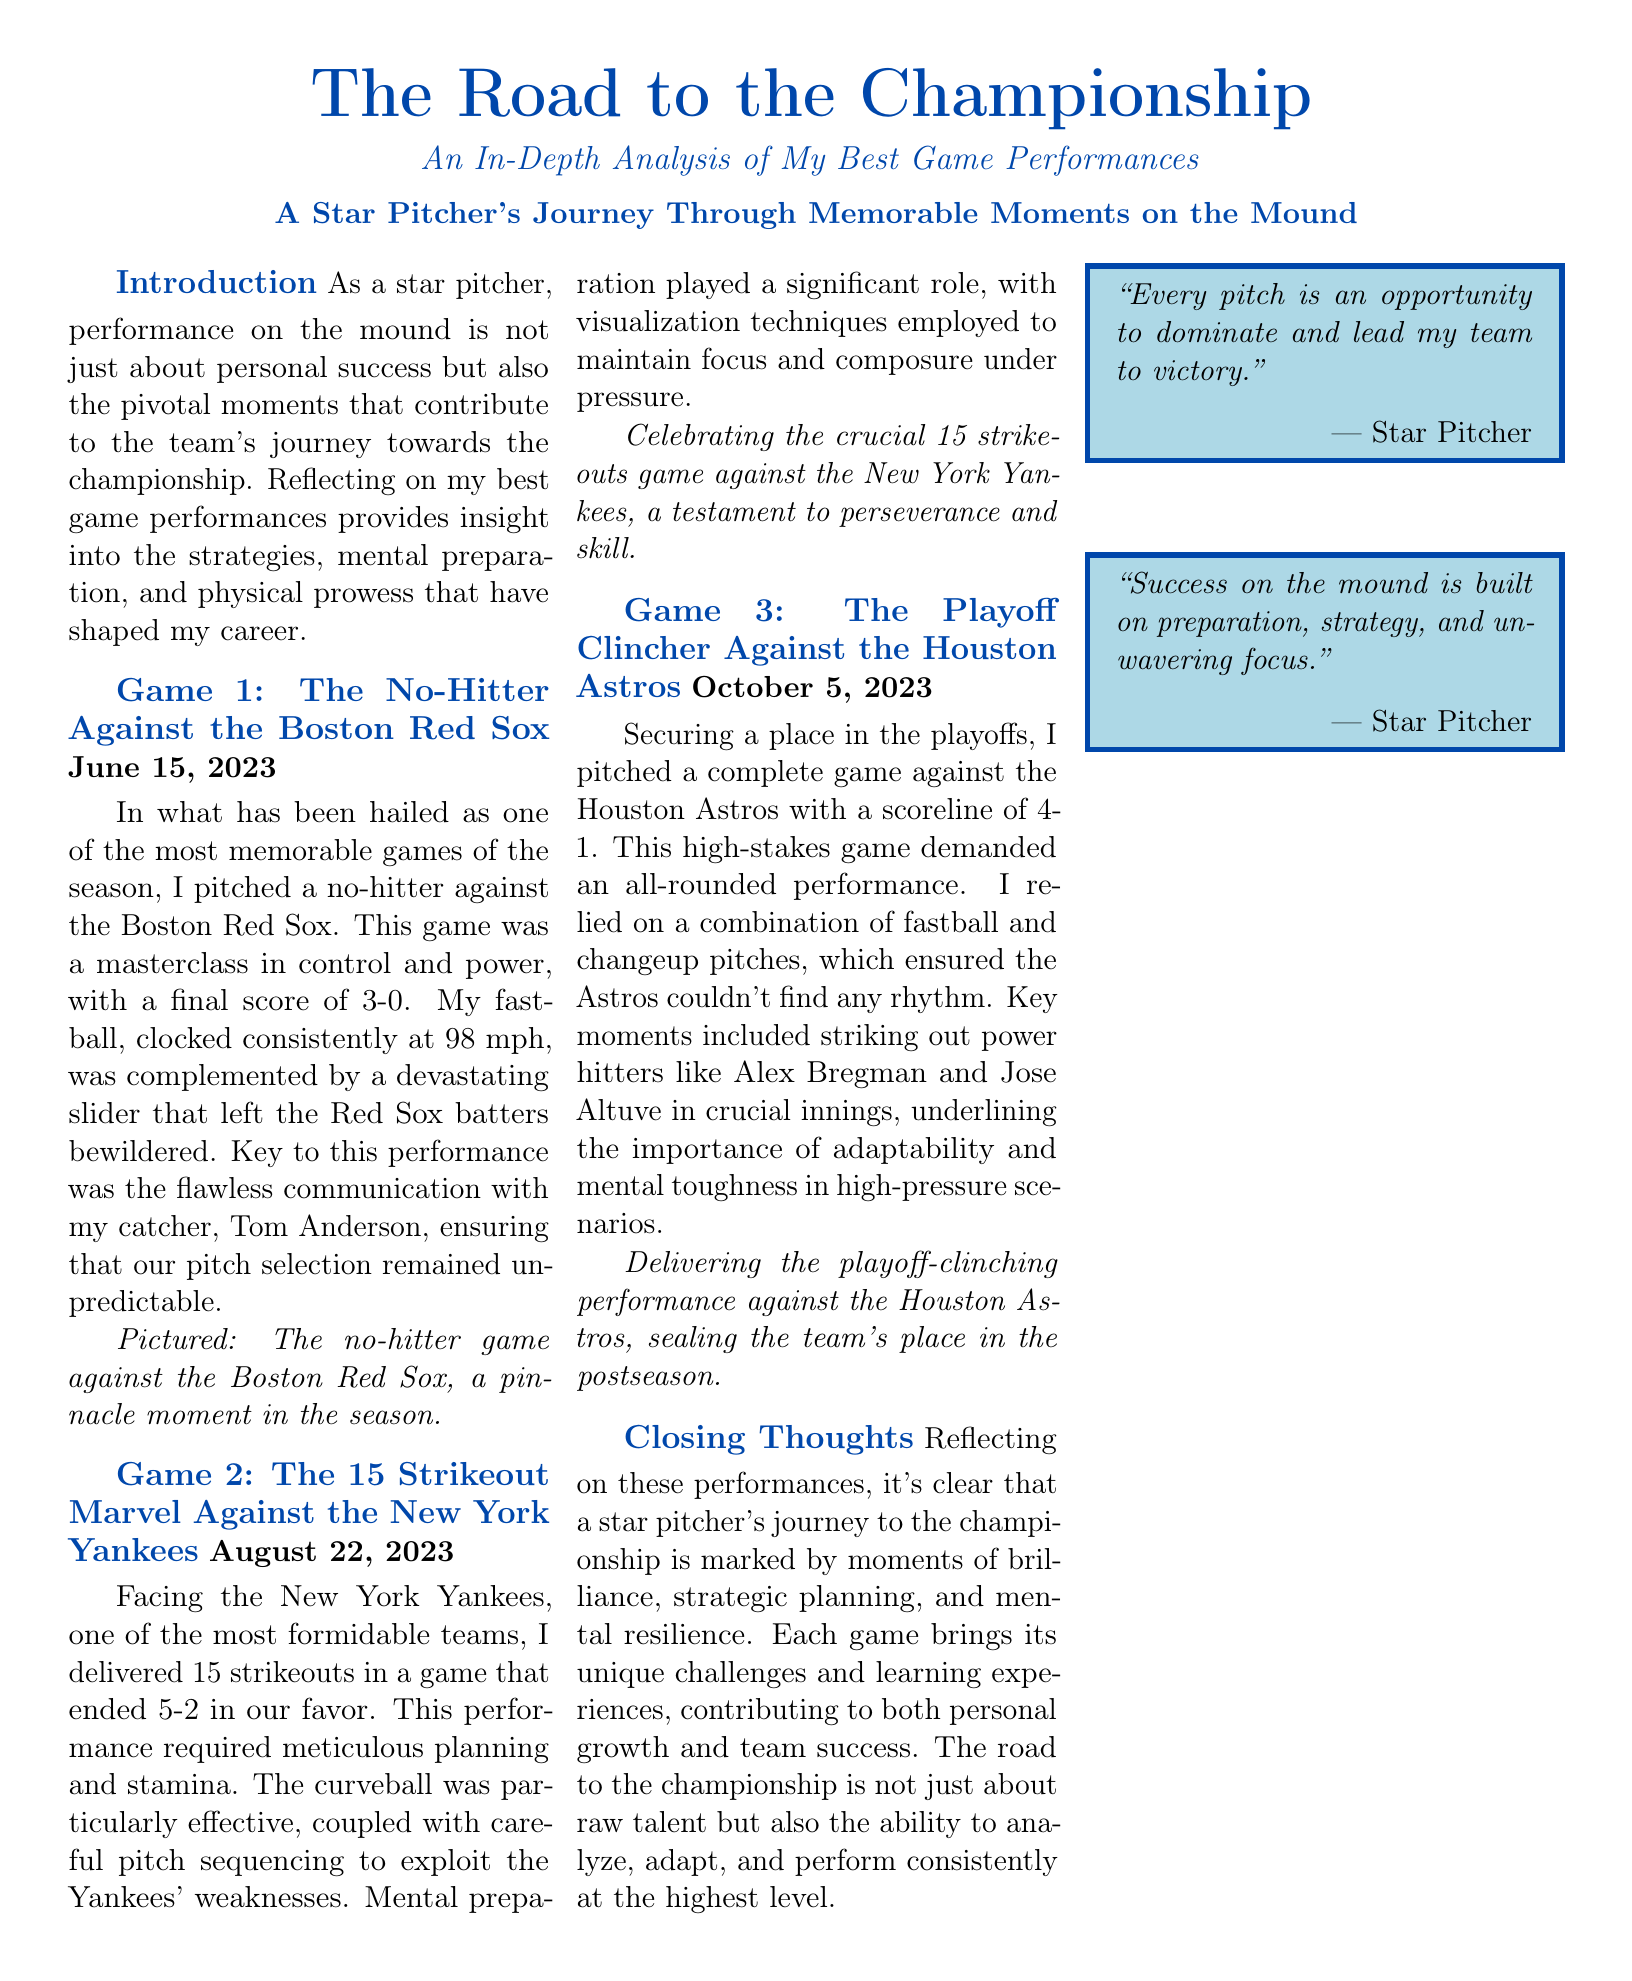What is the title of the document? The title can be found at the top of the document and summarizes the purpose of the analysis.
Answer: The Road to the Championship What date was the no-hitter against the Boston Red Sox? The date of the no-hitter game is explicitly mentioned in the document under the game section.
Answer: June 15, 2023 How many strikeouts did the pitcher achieve against the New York Yankees? The document specifies the number of strikeouts in that particular game.
Answer: 15 What was the final score of the playoff clincher against the Houston Astros? The score is provided in the description of the game against the Astros.
Answer: 4-1 Which pitch was particularly effective against the Yankees? The document highlights a specific pitch that contributed to the performance against the Yankees.
Answer: Curveball What was the key to the performance in the no-hitter game? The analysis provides insight into what was crucial for success in that specific game.
Answer: Flawless communication What theme is explored in the closing thoughts of the document? The closing thoughts summarize the main idea presented throughout the document regarding the pitcher's journey.
Answer: Strategic planning Who is quoted in the quoteboxes? The quotes in the document are attributed to a specific person, as indicated in the quoteboxes.
Answer: Star Pitcher 